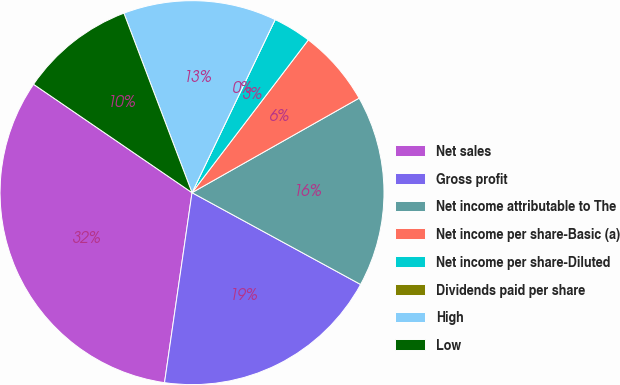<chart> <loc_0><loc_0><loc_500><loc_500><pie_chart><fcel>Net sales<fcel>Gross profit<fcel>Net income attributable to The<fcel>Net income per share-Basic (a)<fcel>Net income per share-Diluted<fcel>Dividends paid per share<fcel>High<fcel>Low<nl><fcel>32.26%<fcel>19.35%<fcel>16.13%<fcel>6.45%<fcel>3.23%<fcel>0.0%<fcel>12.9%<fcel>9.68%<nl></chart> 